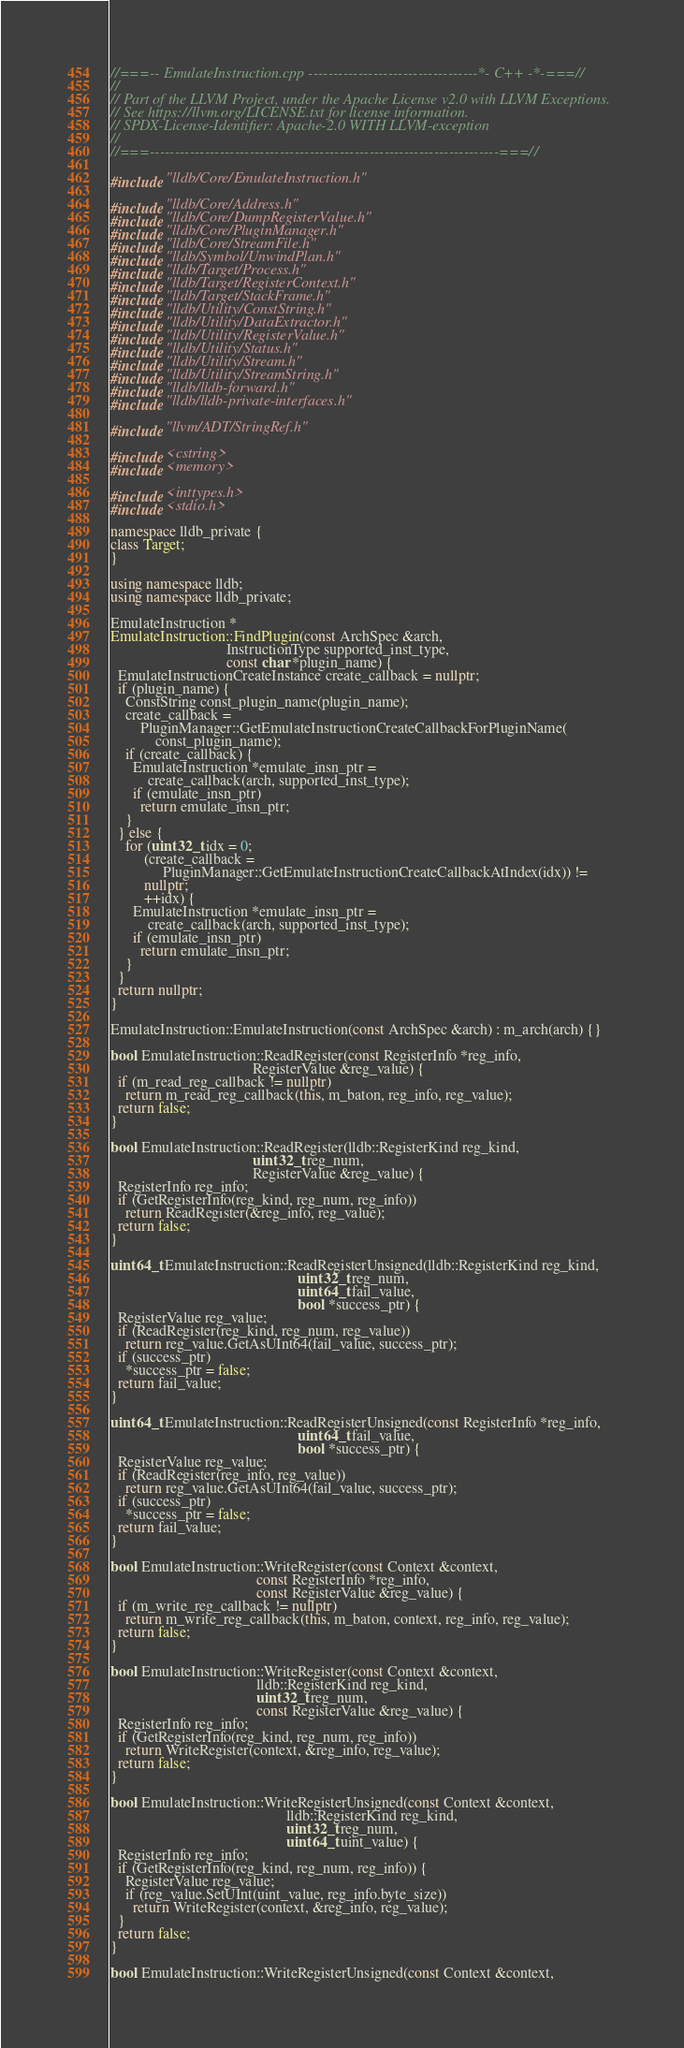<code> <loc_0><loc_0><loc_500><loc_500><_C++_>//===-- EmulateInstruction.cpp ----------------------------------*- C++ -*-===//
//
// Part of the LLVM Project, under the Apache License v2.0 with LLVM Exceptions.
// See https://llvm.org/LICENSE.txt for license information.
// SPDX-License-Identifier: Apache-2.0 WITH LLVM-exception
//
//===----------------------------------------------------------------------===//

#include "lldb/Core/EmulateInstruction.h"

#include "lldb/Core/Address.h"
#include "lldb/Core/DumpRegisterValue.h"
#include "lldb/Core/PluginManager.h"
#include "lldb/Core/StreamFile.h"
#include "lldb/Symbol/UnwindPlan.h"
#include "lldb/Target/Process.h"
#include "lldb/Target/RegisterContext.h"
#include "lldb/Target/StackFrame.h"
#include "lldb/Utility/ConstString.h"
#include "lldb/Utility/DataExtractor.h"
#include "lldb/Utility/RegisterValue.h"
#include "lldb/Utility/Status.h"
#include "lldb/Utility/Stream.h"
#include "lldb/Utility/StreamString.h"
#include "lldb/lldb-forward.h"
#include "lldb/lldb-private-interfaces.h"

#include "llvm/ADT/StringRef.h"

#include <cstring>
#include <memory>

#include <inttypes.h>
#include <stdio.h>

namespace lldb_private {
class Target;
}

using namespace lldb;
using namespace lldb_private;

EmulateInstruction *
EmulateInstruction::FindPlugin(const ArchSpec &arch,
                               InstructionType supported_inst_type,
                               const char *plugin_name) {
  EmulateInstructionCreateInstance create_callback = nullptr;
  if (plugin_name) {
    ConstString const_plugin_name(plugin_name);
    create_callback =
        PluginManager::GetEmulateInstructionCreateCallbackForPluginName(
            const_plugin_name);
    if (create_callback) {
      EmulateInstruction *emulate_insn_ptr =
          create_callback(arch, supported_inst_type);
      if (emulate_insn_ptr)
        return emulate_insn_ptr;
    }
  } else {
    for (uint32_t idx = 0;
         (create_callback =
              PluginManager::GetEmulateInstructionCreateCallbackAtIndex(idx)) !=
         nullptr;
         ++idx) {
      EmulateInstruction *emulate_insn_ptr =
          create_callback(arch, supported_inst_type);
      if (emulate_insn_ptr)
        return emulate_insn_ptr;
    }
  }
  return nullptr;
}

EmulateInstruction::EmulateInstruction(const ArchSpec &arch) : m_arch(arch) {}

bool EmulateInstruction::ReadRegister(const RegisterInfo *reg_info,
                                      RegisterValue &reg_value) {
  if (m_read_reg_callback != nullptr)
    return m_read_reg_callback(this, m_baton, reg_info, reg_value);
  return false;
}

bool EmulateInstruction::ReadRegister(lldb::RegisterKind reg_kind,
                                      uint32_t reg_num,
                                      RegisterValue &reg_value) {
  RegisterInfo reg_info;
  if (GetRegisterInfo(reg_kind, reg_num, reg_info))
    return ReadRegister(&reg_info, reg_value);
  return false;
}

uint64_t EmulateInstruction::ReadRegisterUnsigned(lldb::RegisterKind reg_kind,
                                                  uint32_t reg_num,
                                                  uint64_t fail_value,
                                                  bool *success_ptr) {
  RegisterValue reg_value;
  if (ReadRegister(reg_kind, reg_num, reg_value))
    return reg_value.GetAsUInt64(fail_value, success_ptr);
  if (success_ptr)
    *success_ptr = false;
  return fail_value;
}

uint64_t EmulateInstruction::ReadRegisterUnsigned(const RegisterInfo *reg_info,
                                                  uint64_t fail_value,
                                                  bool *success_ptr) {
  RegisterValue reg_value;
  if (ReadRegister(reg_info, reg_value))
    return reg_value.GetAsUInt64(fail_value, success_ptr);
  if (success_ptr)
    *success_ptr = false;
  return fail_value;
}

bool EmulateInstruction::WriteRegister(const Context &context,
                                       const RegisterInfo *reg_info,
                                       const RegisterValue &reg_value) {
  if (m_write_reg_callback != nullptr)
    return m_write_reg_callback(this, m_baton, context, reg_info, reg_value);
  return false;
}

bool EmulateInstruction::WriteRegister(const Context &context,
                                       lldb::RegisterKind reg_kind,
                                       uint32_t reg_num,
                                       const RegisterValue &reg_value) {
  RegisterInfo reg_info;
  if (GetRegisterInfo(reg_kind, reg_num, reg_info))
    return WriteRegister(context, &reg_info, reg_value);
  return false;
}

bool EmulateInstruction::WriteRegisterUnsigned(const Context &context,
                                               lldb::RegisterKind reg_kind,
                                               uint32_t reg_num,
                                               uint64_t uint_value) {
  RegisterInfo reg_info;
  if (GetRegisterInfo(reg_kind, reg_num, reg_info)) {
    RegisterValue reg_value;
    if (reg_value.SetUInt(uint_value, reg_info.byte_size))
      return WriteRegister(context, &reg_info, reg_value);
  }
  return false;
}

bool EmulateInstruction::WriteRegisterUnsigned(const Context &context,</code> 